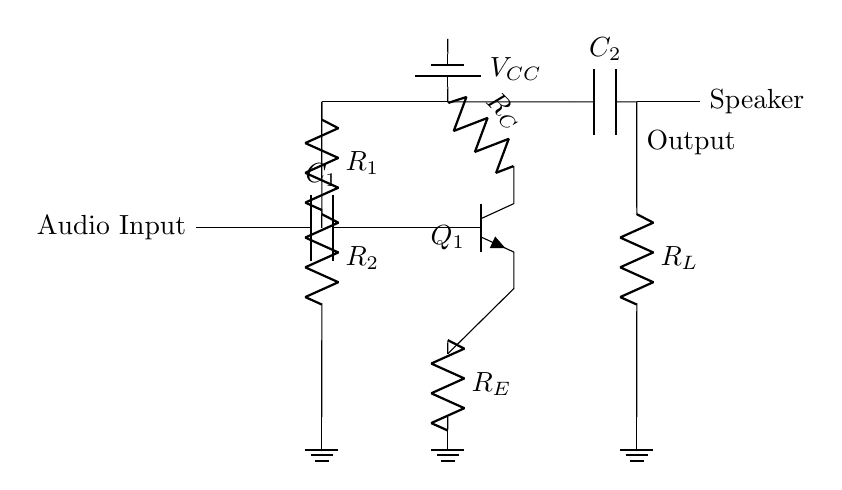What type of transistor is used in this circuit? The circuit uses an NPN transistor, identifiable by the markings in the diagram, specifically labeled as Q1.
Answer: NPN What is the value of the load resistor in the circuit? The circuit label indicates that there is a resistor denoted as RL connected to the speaker, but the specific resistance value isn't shown. Thus, the value may vary depending on the design requirements.
Answer: Not specified How many capacitors are present in the circuit? The circuit contains two capacitors, indicated by the symbols connected to the audio input and output.
Answer: Two What is the purpose of the capacitor C1? Capacitor C1 allows AC signals (audio) to pass while blocking DC components from the input, ensuring that the amplifier only processes the intended audio signal rather than any potentially damaging steady voltage.
Answer: Coupling What is the function of the resistor RE in this circuit? Resistor RE acts as an emitter resistor, which helps to stabilize the transistor’s operation, setting the biasing condition and controlling its gain while improving linearity.
Answer: Emitter stabilization What type of power source is used in this circuit? The power source shown connected to the circuit is a battery, as indicated by the symbol with the label VCC.
Answer: Battery What is the output connection in this circuit? The output connection is made to the speaker via a capacitor C2, which transmits the amplified audio signal while isolating it from the DC supply.
Answer: Speaker 